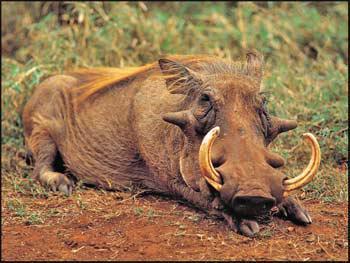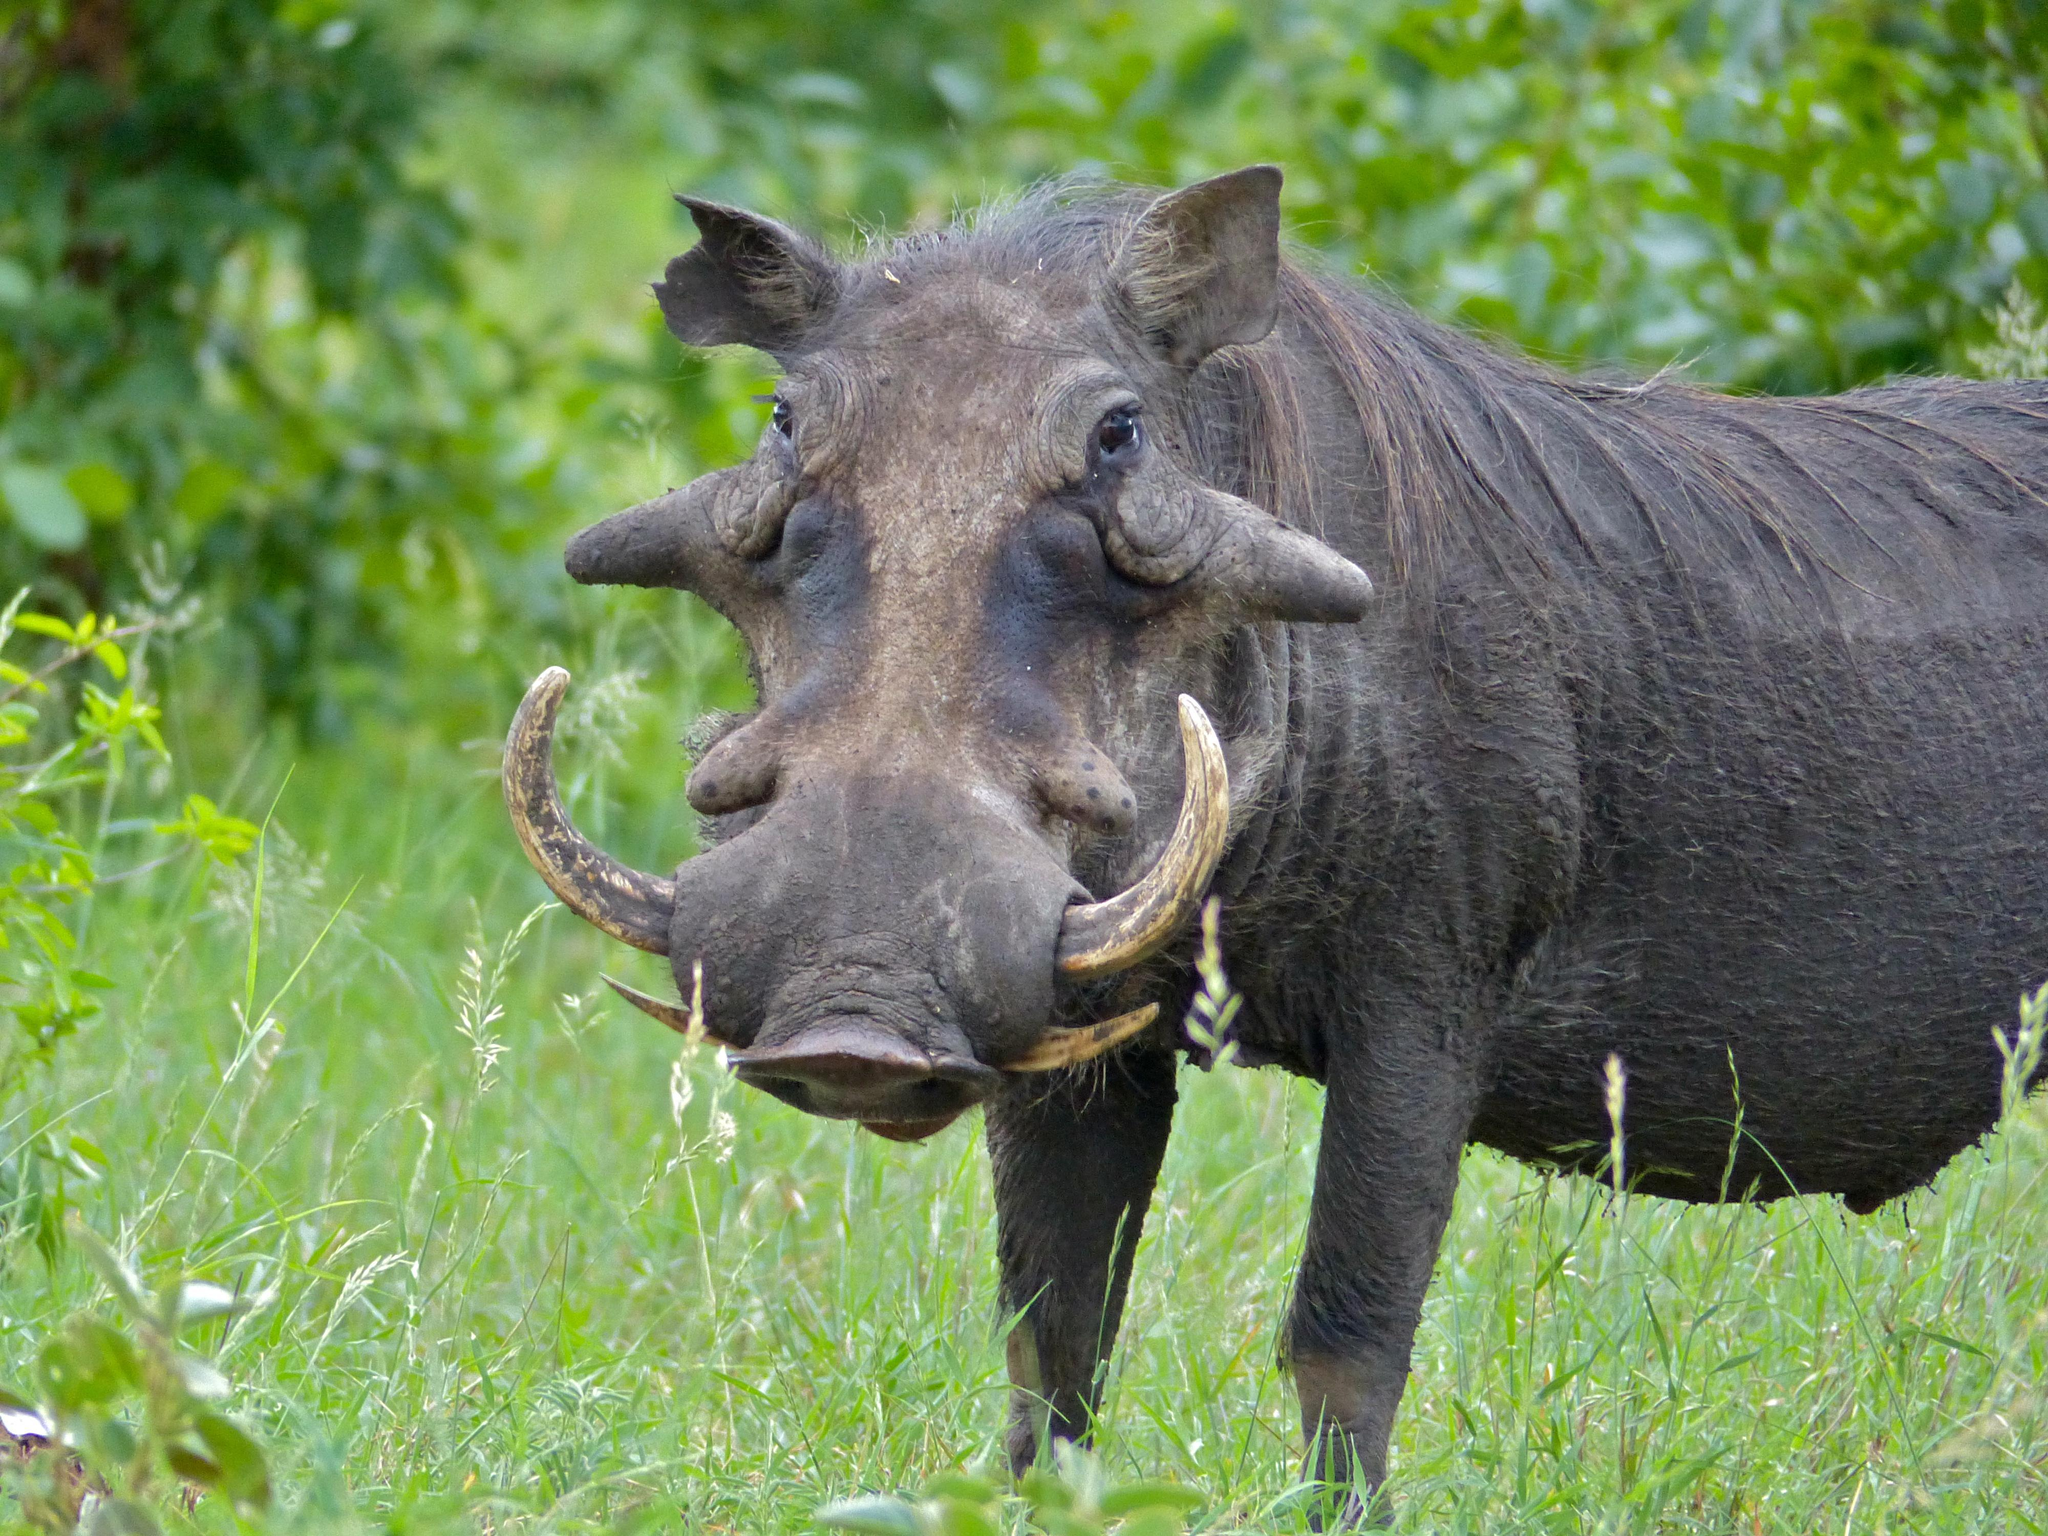The first image is the image on the left, the second image is the image on the right. For the images displayed, is the sentence "One of the images shows an animal in close proximity to water." factually correct? Answer yes or no. No. 